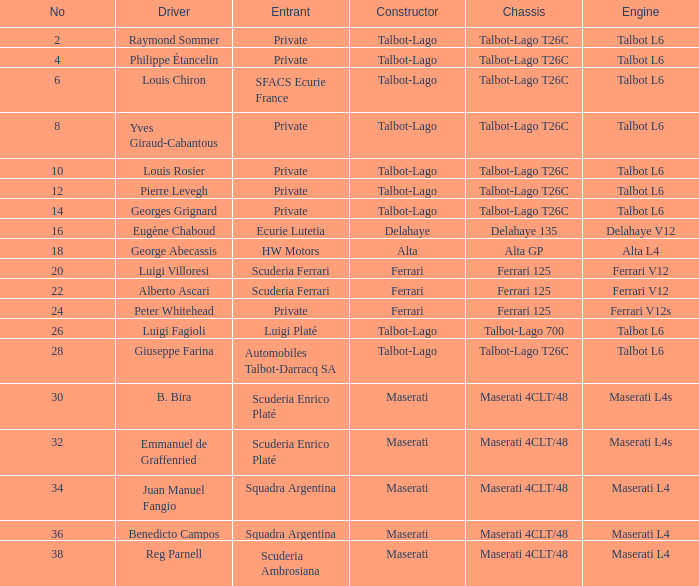Name the chassis for sfacs ecurie france Talbot-Lago T26C. 